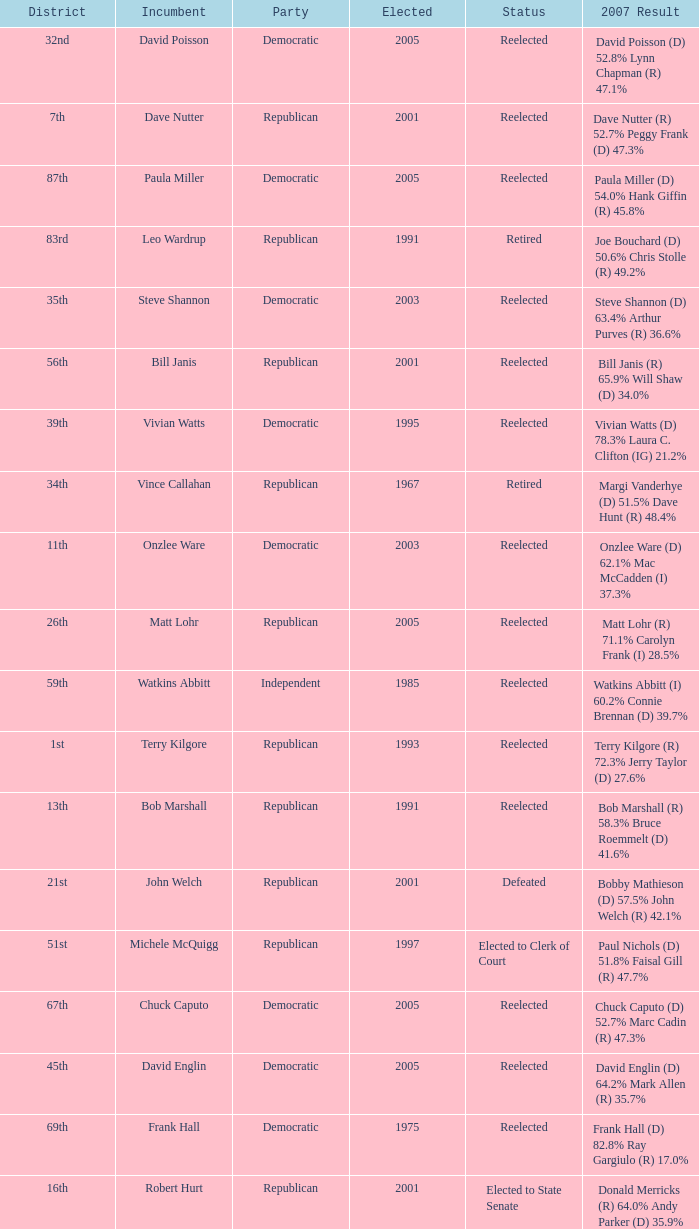How many times was incumbent onzlee ware elected? 1.0. 